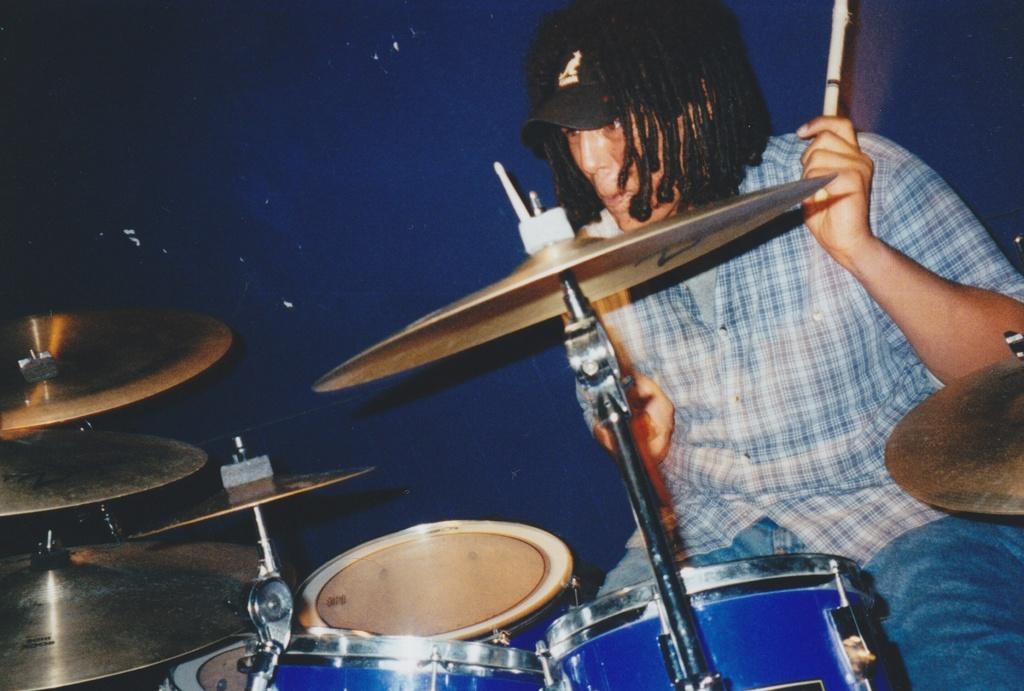What is the main activity being performed in the image? There is a person playing drums in the image. What other percussion instrument is visible in the image? Cymbals are present in the image. What type of headwear is the person wearing? The person is wearing a cap. What can be seen in the background of the image? There is a wall in the background of the image. How many girls are playing the drums in the image? There is no girl present in the image; it features a person playing drums who may or may not be a girl. What type of lipstick is the person wearing in the image? There is no lipstick visible in the image, as the person's lips are not shown. 